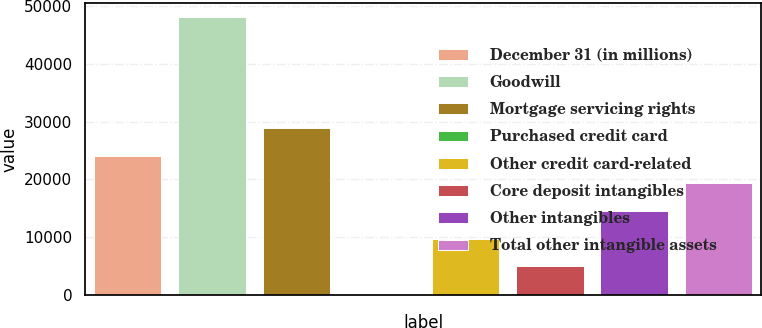Convert chart. <chart><loc_0><loc_0><loc_500><loc_500><bar_chart><fcel>December 31 (in millions)<fcel>Goodwill<fcel>Mortgage servicing rights<fcel>Purchased credit card<fcel>Other credit card-related<fcel>Core deposit intangibles<fcel>Other intangibles<fcel>Total other intangible assets<nl><fcel>24106<fcel>48081<fcel>28901<fcel>131<fcel>9721<fcel>4926<fcel>14516<fcel>19311<nl></chart> 